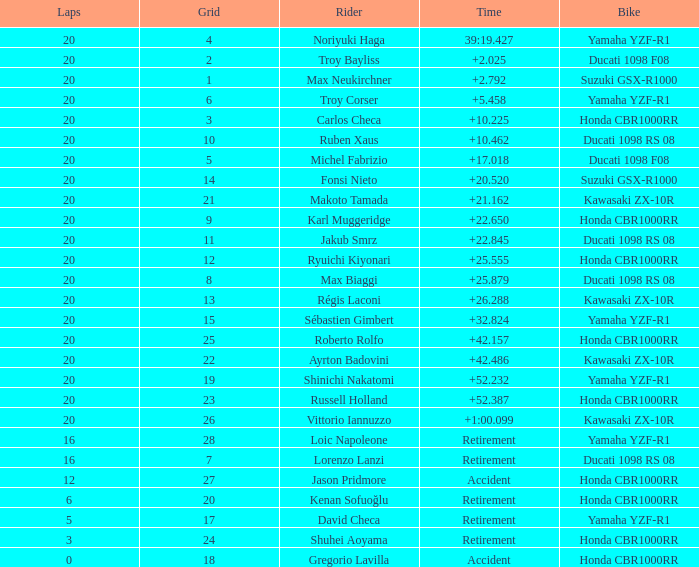What is the time of Max Biaggi with more than 2 grids, 20 laps? 25.879. 